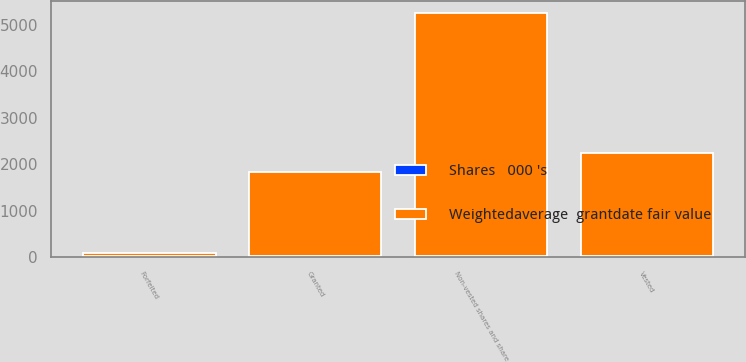Convert chart. <chart><loc_0><loc_0><loc_500><loc_500><stacked_bar_chart><ecel><fcel>Non-vested shares and share<fcel>Granted<fcel>Vested<fcel>Forfeited<nl><fcel>Weightedaverage  grantdate fair value<fcel>5242<fcel>1815<fcel>2238<fcel>72<nl><fcel>Shares   000 's<fcel>17.91<fcel>21.49<fcel>14.35<fcel>21.11<nl></chart> 